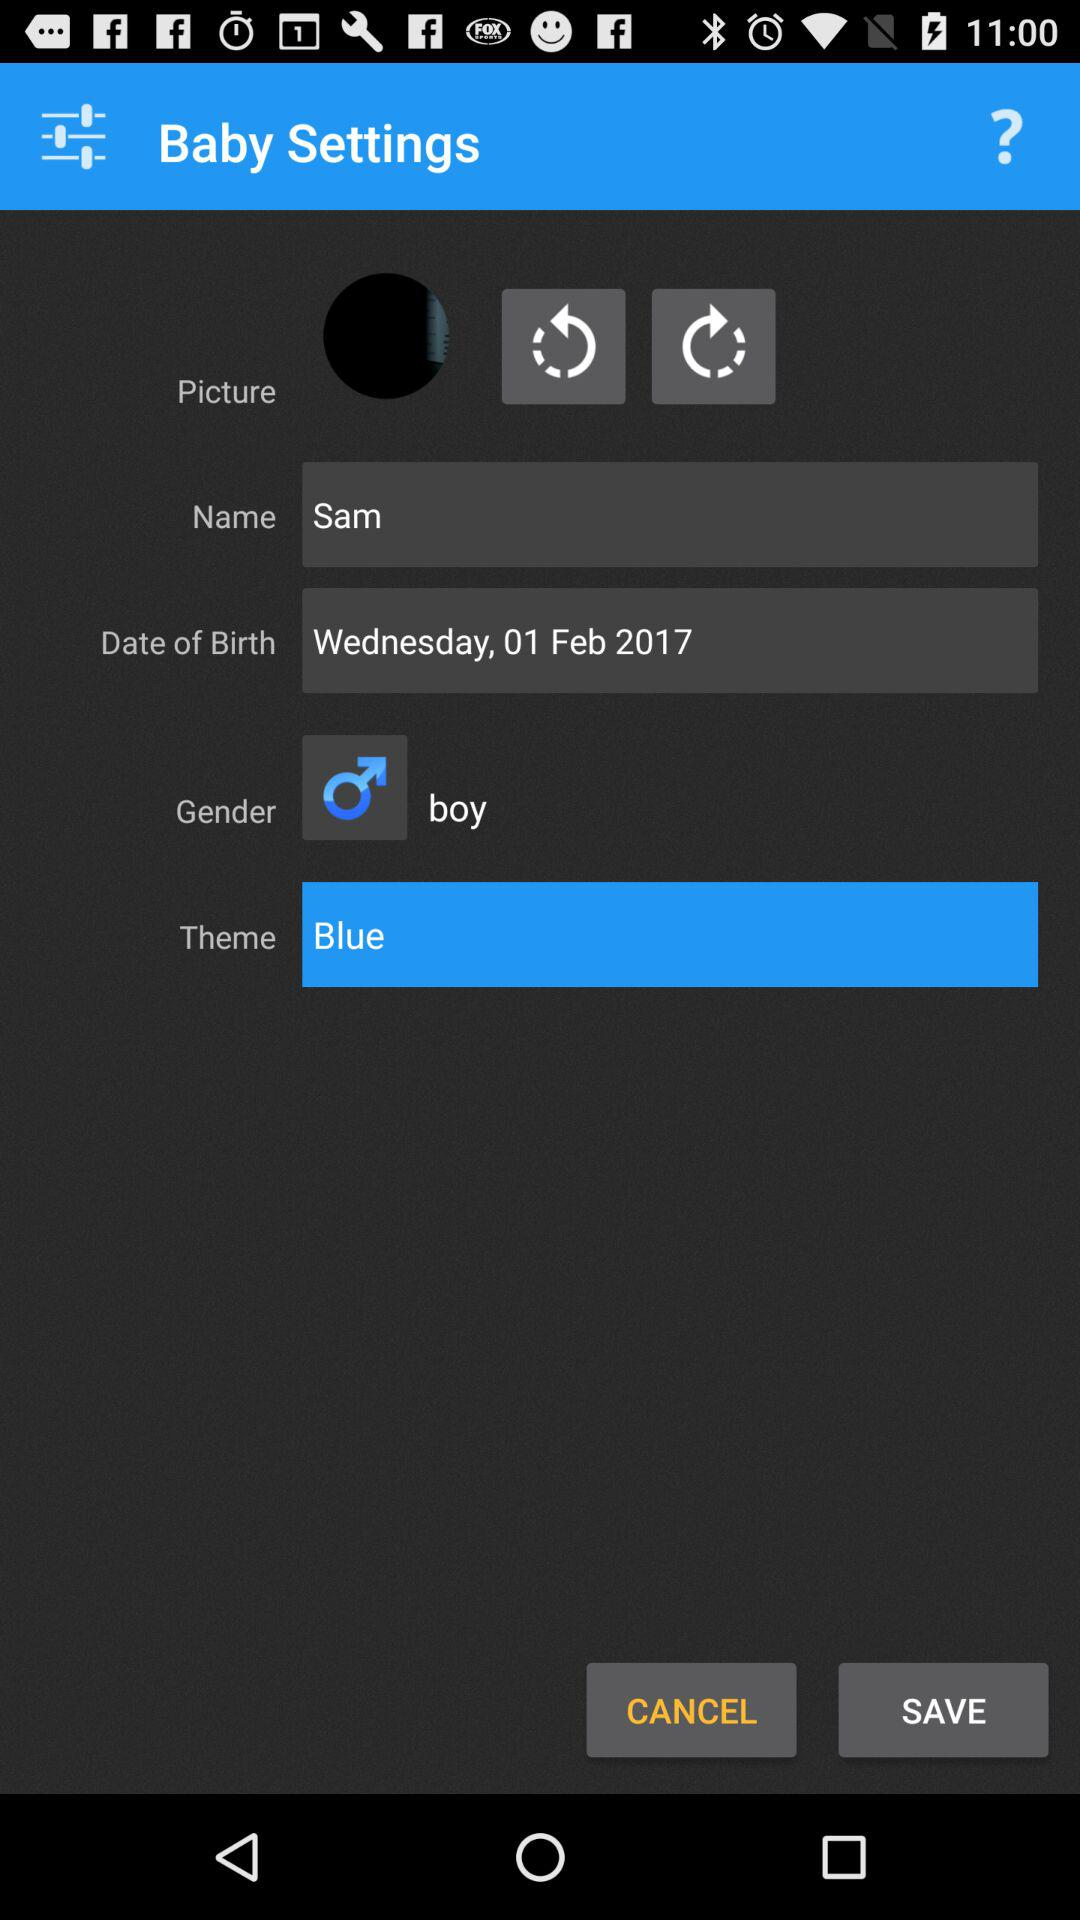What is the gender of a user? The gender is a boy. 